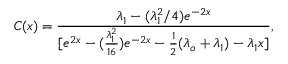<formula> <loc_0><loc_0><loc_500><loc_500>C ( x ) = \frac { \lambda _ { 1 } - ( \lambda _ { 1 } ^ { 2 } / 4 ) e ^ { - 2 x } } { [ e ^ { 2 x } - ( \frac { \lambda _ { 1 } ^ { 2 } } { 1 6 } ) e ^ { - 2 x } - \frac { 1 } { 2 } ( \lambda _ { o } + \lambda _ { 1 } ) - \lambda _ { 1 } x ] } ,</formula> 